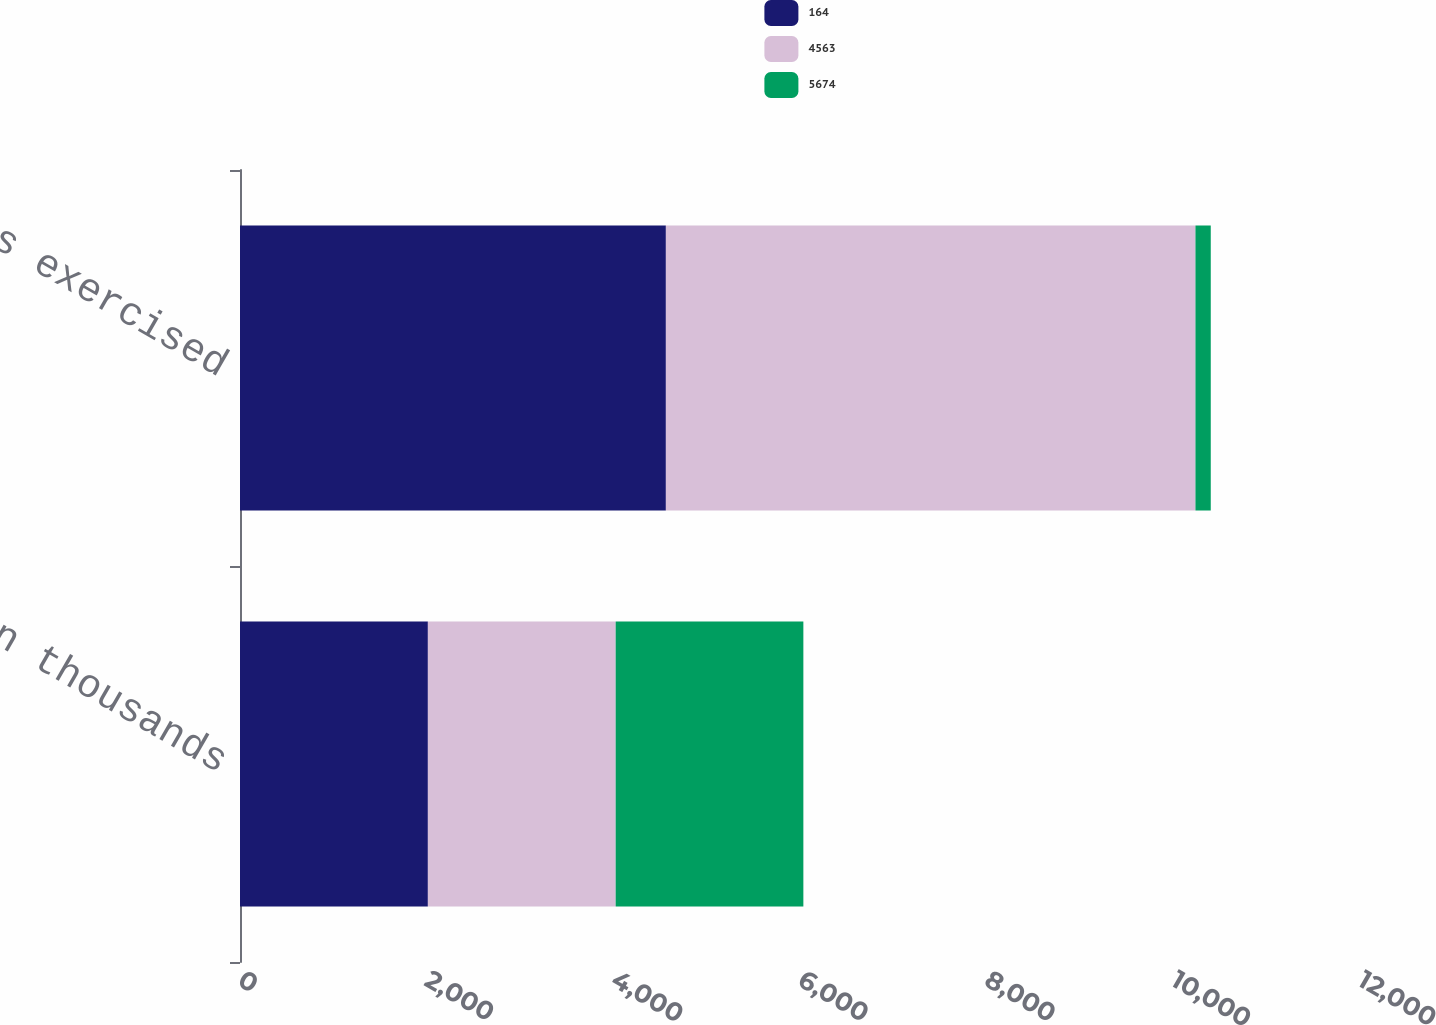<chart> <loc_0><loc_0><loc_500><loc_500><stacked_bar_chart><ecel><fcel>in thousands<fcel>SOSARs exercised<nl><fcel>164<fcel>2013<fcel>4563<nl><fcel>4563<fcel>2012<fcel>5674<nl><fcel>5674<fcel>2011<fcel>164<nl></chart> 